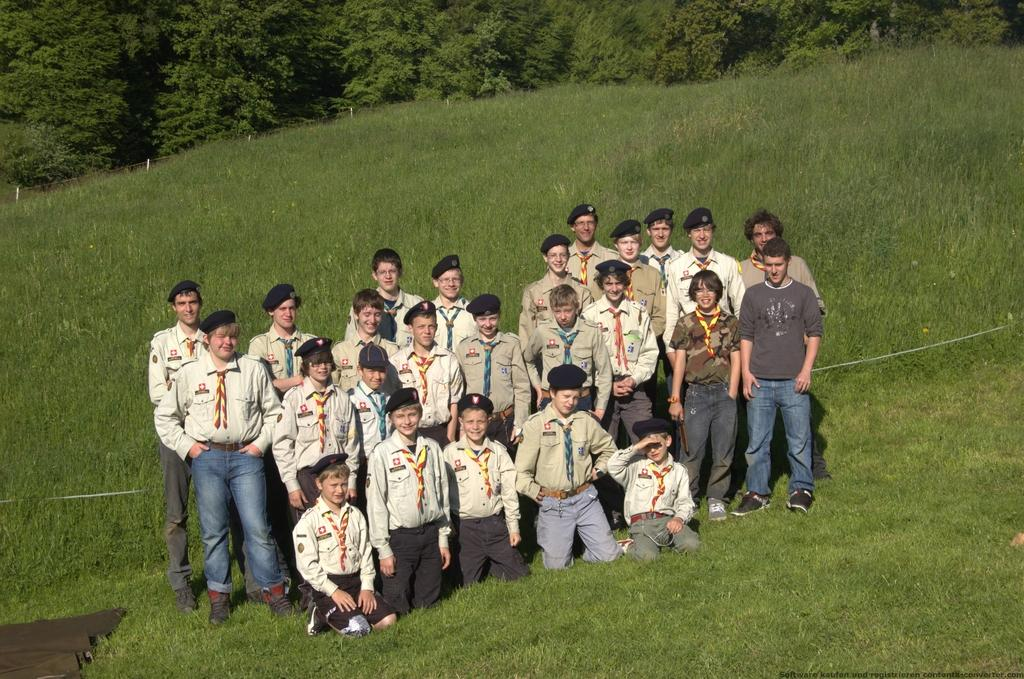What is the main subject of the image? The main subject of the image is a group of people. What are some of the people in the group doing? Some people in the group are kneeling on the grass, while others are standing. What can be seen in the background of the image? There are trees in the background of the image. What type of treatment is being administered to the person wearing a veil in the image? There is no person wearing a veil in the image, and no treatment is being administered. Is there a spy present in the image? There is no indication of a spy in the image; it features a group of people in various positions. 